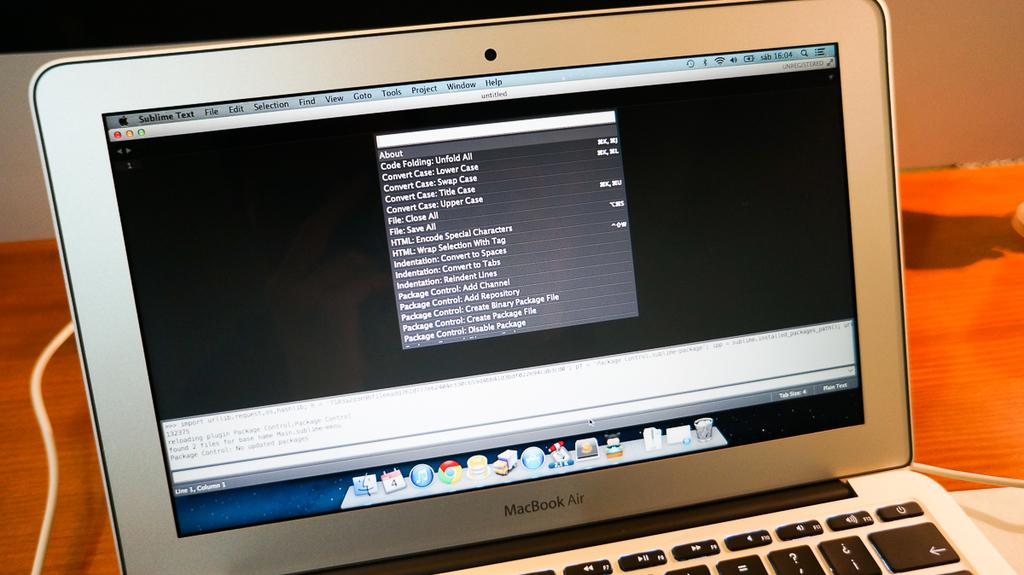<image>
Offer a succinct explanation of the picture presented. Macbook air laptop that is showing the full home screen 